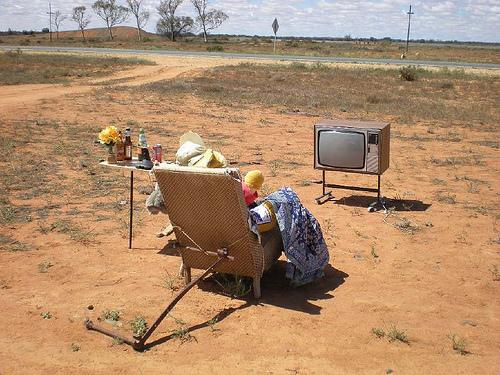What's connected to the back of the chair? Please explain your reasoning. metal rod. The pole is there to keep the chair from moving. 